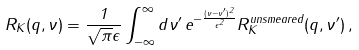<formula> <loc_0><loc_0><loc_500><loc_500>R _ { K } ( q , \nu ) = \frac { 1 } { \sqrt { \pi } \epsilon } \int _ { - \infty } ^ { \infty } d \nu ^ { \prime } \, e ^ { - \frac { ( \nu - \nu ^ { \prime } ) ^ { 2 } } { \epsilon ^ { 2 } } } R _ { K } ^ { u n s m e a r e d } ( q , \nu ^ { \prime } ) \, ,</formula> 